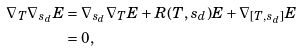Convert formula to latex. <formula><loc_0><loc_0><loc_500><loc_500>\nabla _ { T } \nabla _ { s _ { d } } E & = \nabla _ { s _ { d } } \nabla _ { T } E + R ( T , s _ { d } ) E + \nabla _ { [ T , s _ { d } ] } E \\ & = 0 ,</formula> 